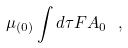Convert formula to latex. <formula><loc_0><loc_0><loc_500><loc_500>\mu _ { ( 0 ) } \int d \tau F A _ { 0 } \ ,</formula> 